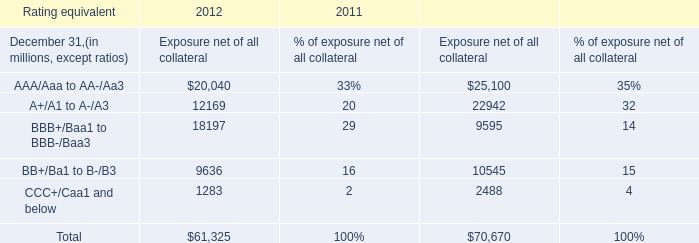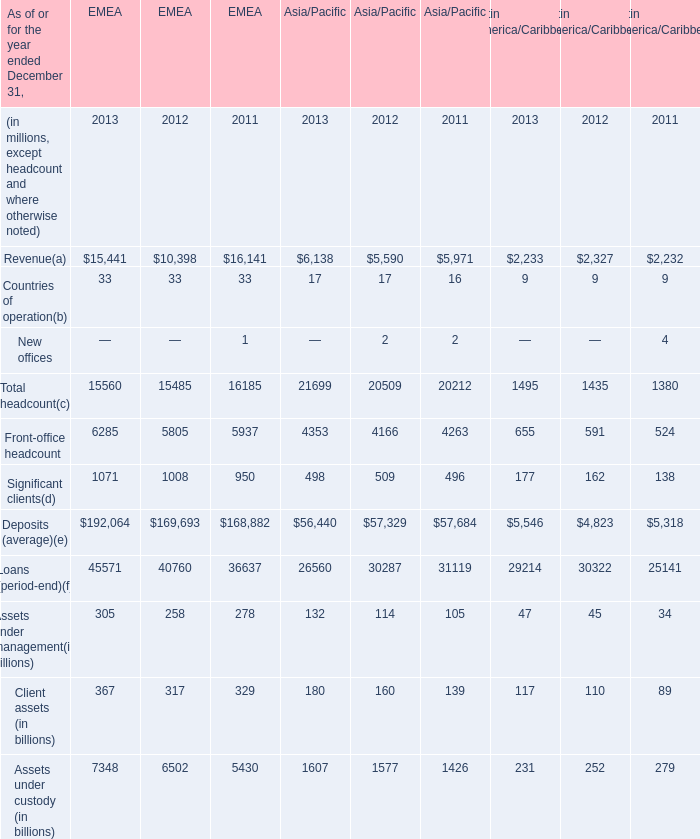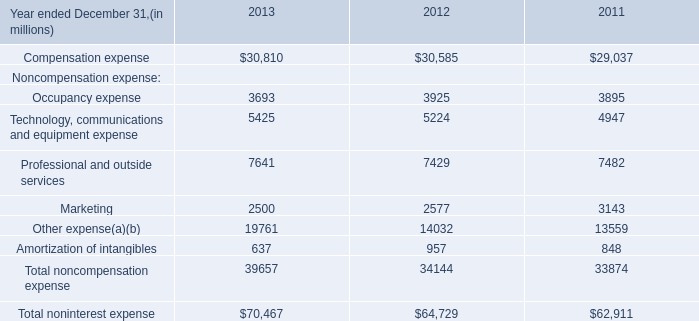What was the average value of Front-office headcount, Significant clients, Deposits (average) in 2013 for Asia/Pacific? (in million) 
Computations: (((4353 + 498) + 56440) / 3)
Answer: 20430.33333. 